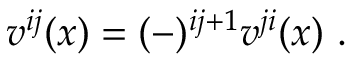<formula> <loc_0><loc_0><loc_500><loc_500>v ^ { i j } ( x ) = ( - ) ^ { i j + 1 } v ^ { j i } ( x ) \ .</formula> 